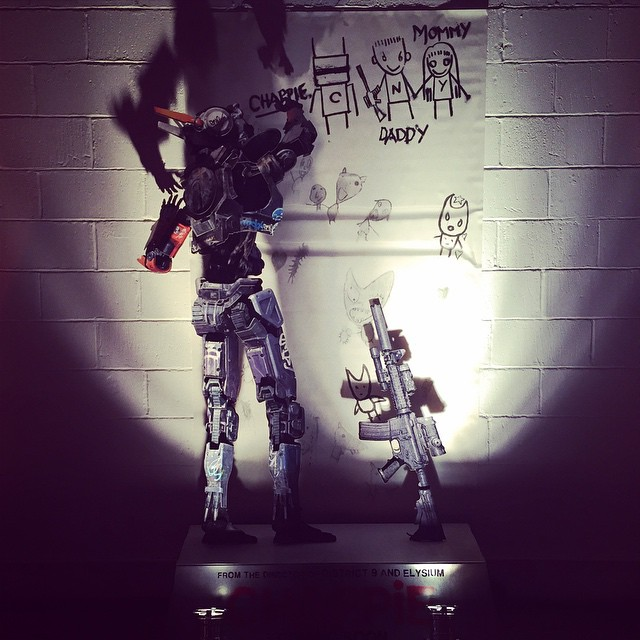What does the presence of child-like drawings behind the robotic figure suggest about the intended emotional impact of this display? The presence of child-like drawings behind the robotic figure suggests a deliberate juxtaposition that blends innocence with technological complexity. This contrast is likely intended to evoke emotions of nostalgia, protectiveness, and a sense of wonder. The child-like drawings may indicate that the robot has a place within a family setting, potentially as a guardian or companion to children, adding layers of emotional depth to its mechanical form. This combination underscores themes of coexistence between humanity and advanced technology, highlighting how even in a high-tech world, human elements and connections remain central and impactful. 